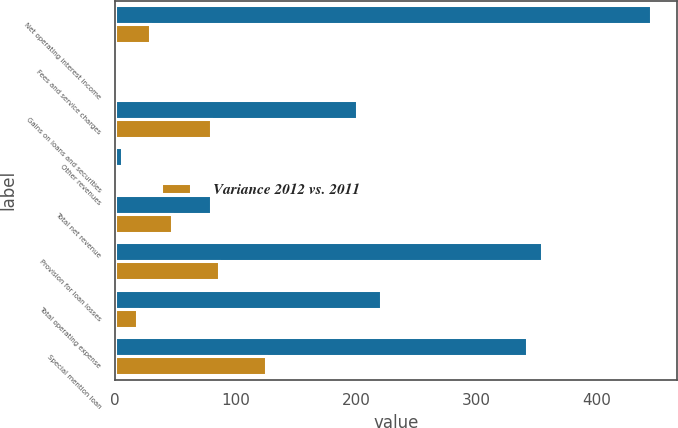<chart> <loc_0><loc_0><loc_500><loc_500><stacked_bar_chart><ecel><fcel>Net operating interest income<fcel>Fees and service charges<fcel>Gains on loans and securities<fcel>Other revenues<fcel>Total net revenue<fcel>Provision for loan losses<fcel>Total operating expense<fcel>Special mention loan<nl><fcel>nan<fcel>444.6<fcel>2.8<fcel>200.8<fcel>5.5<fcel>79.6<fcel>354.6<fcel>220.6<fcel>342.2<nl><fcel>Variance 2012 vs. 2011<fcel>29.3<fcel>0.4<fcel>79.6<fcel>1.7<fcel>47<fcel>86<fcel>17.8<fcel>124.9<nl></chart> 